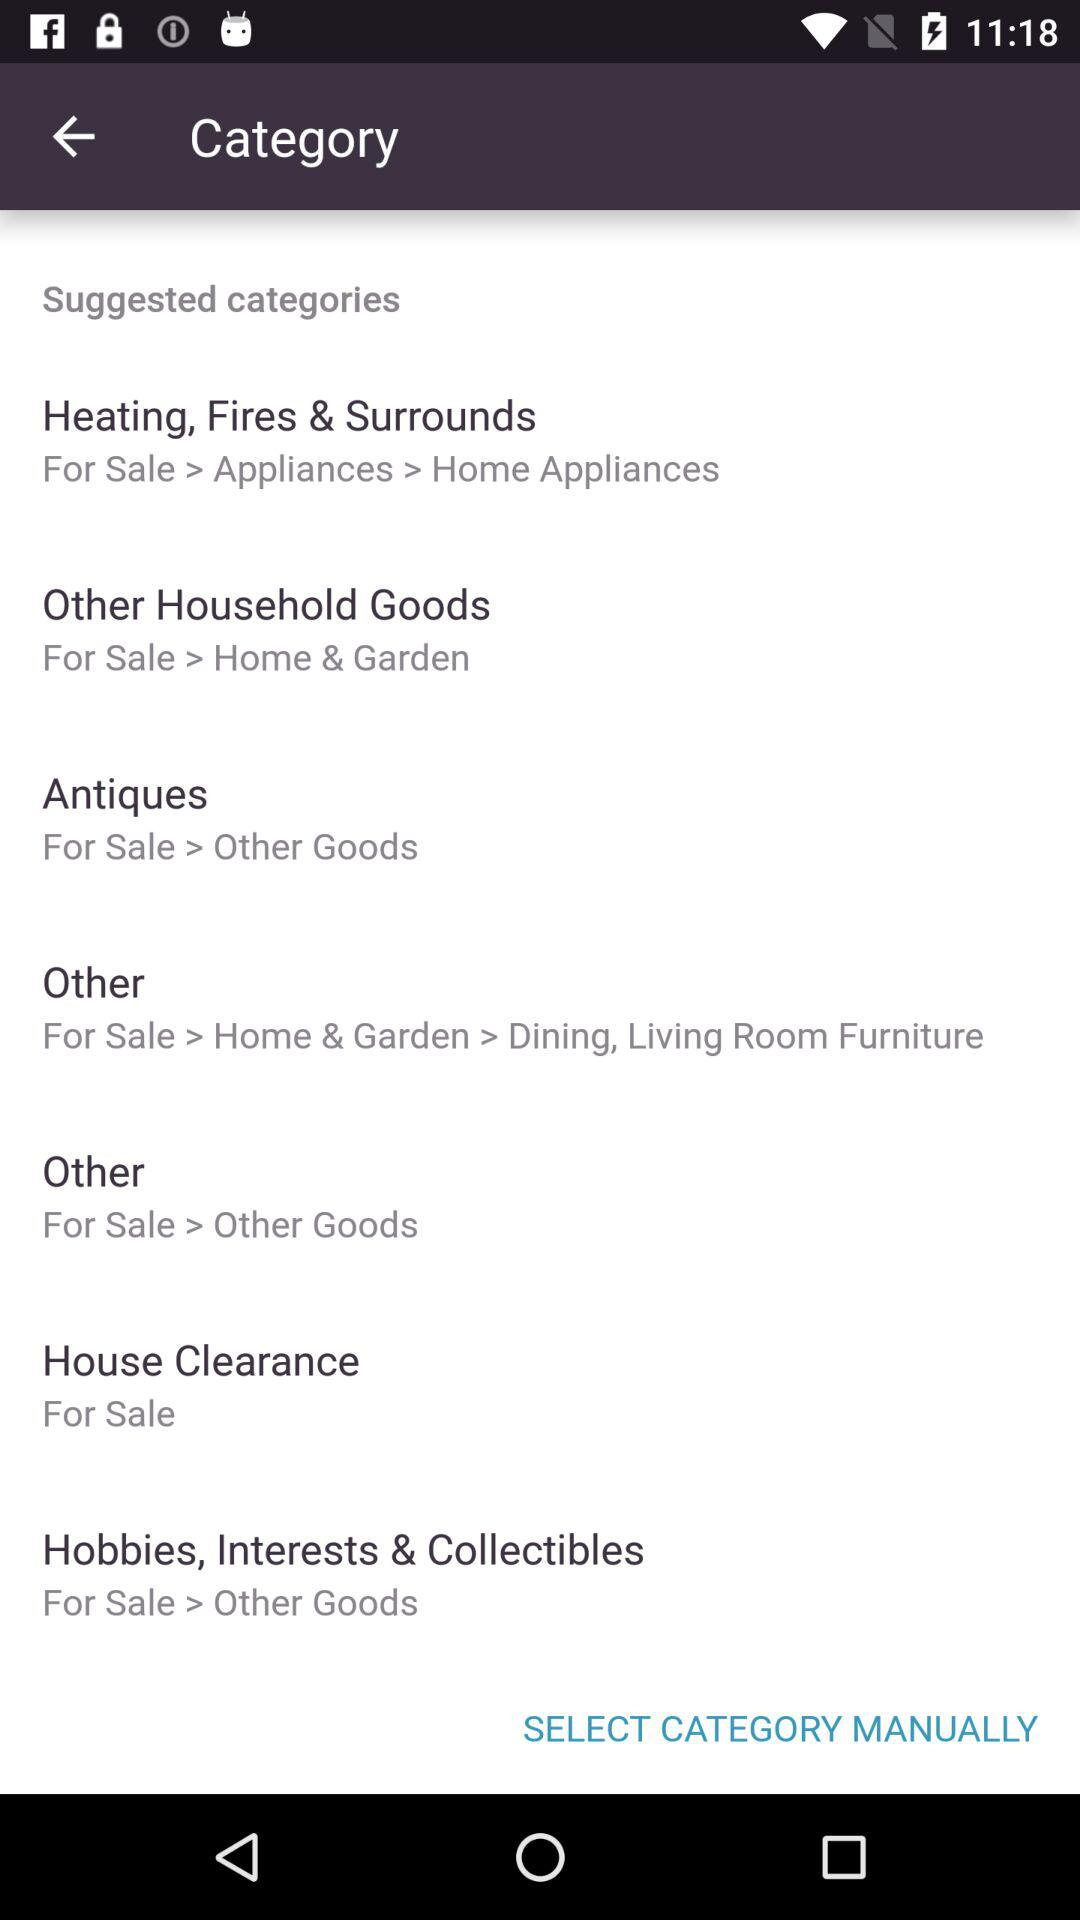How many suggested categories are there?
Answer the question using a single word or phrase. 8 